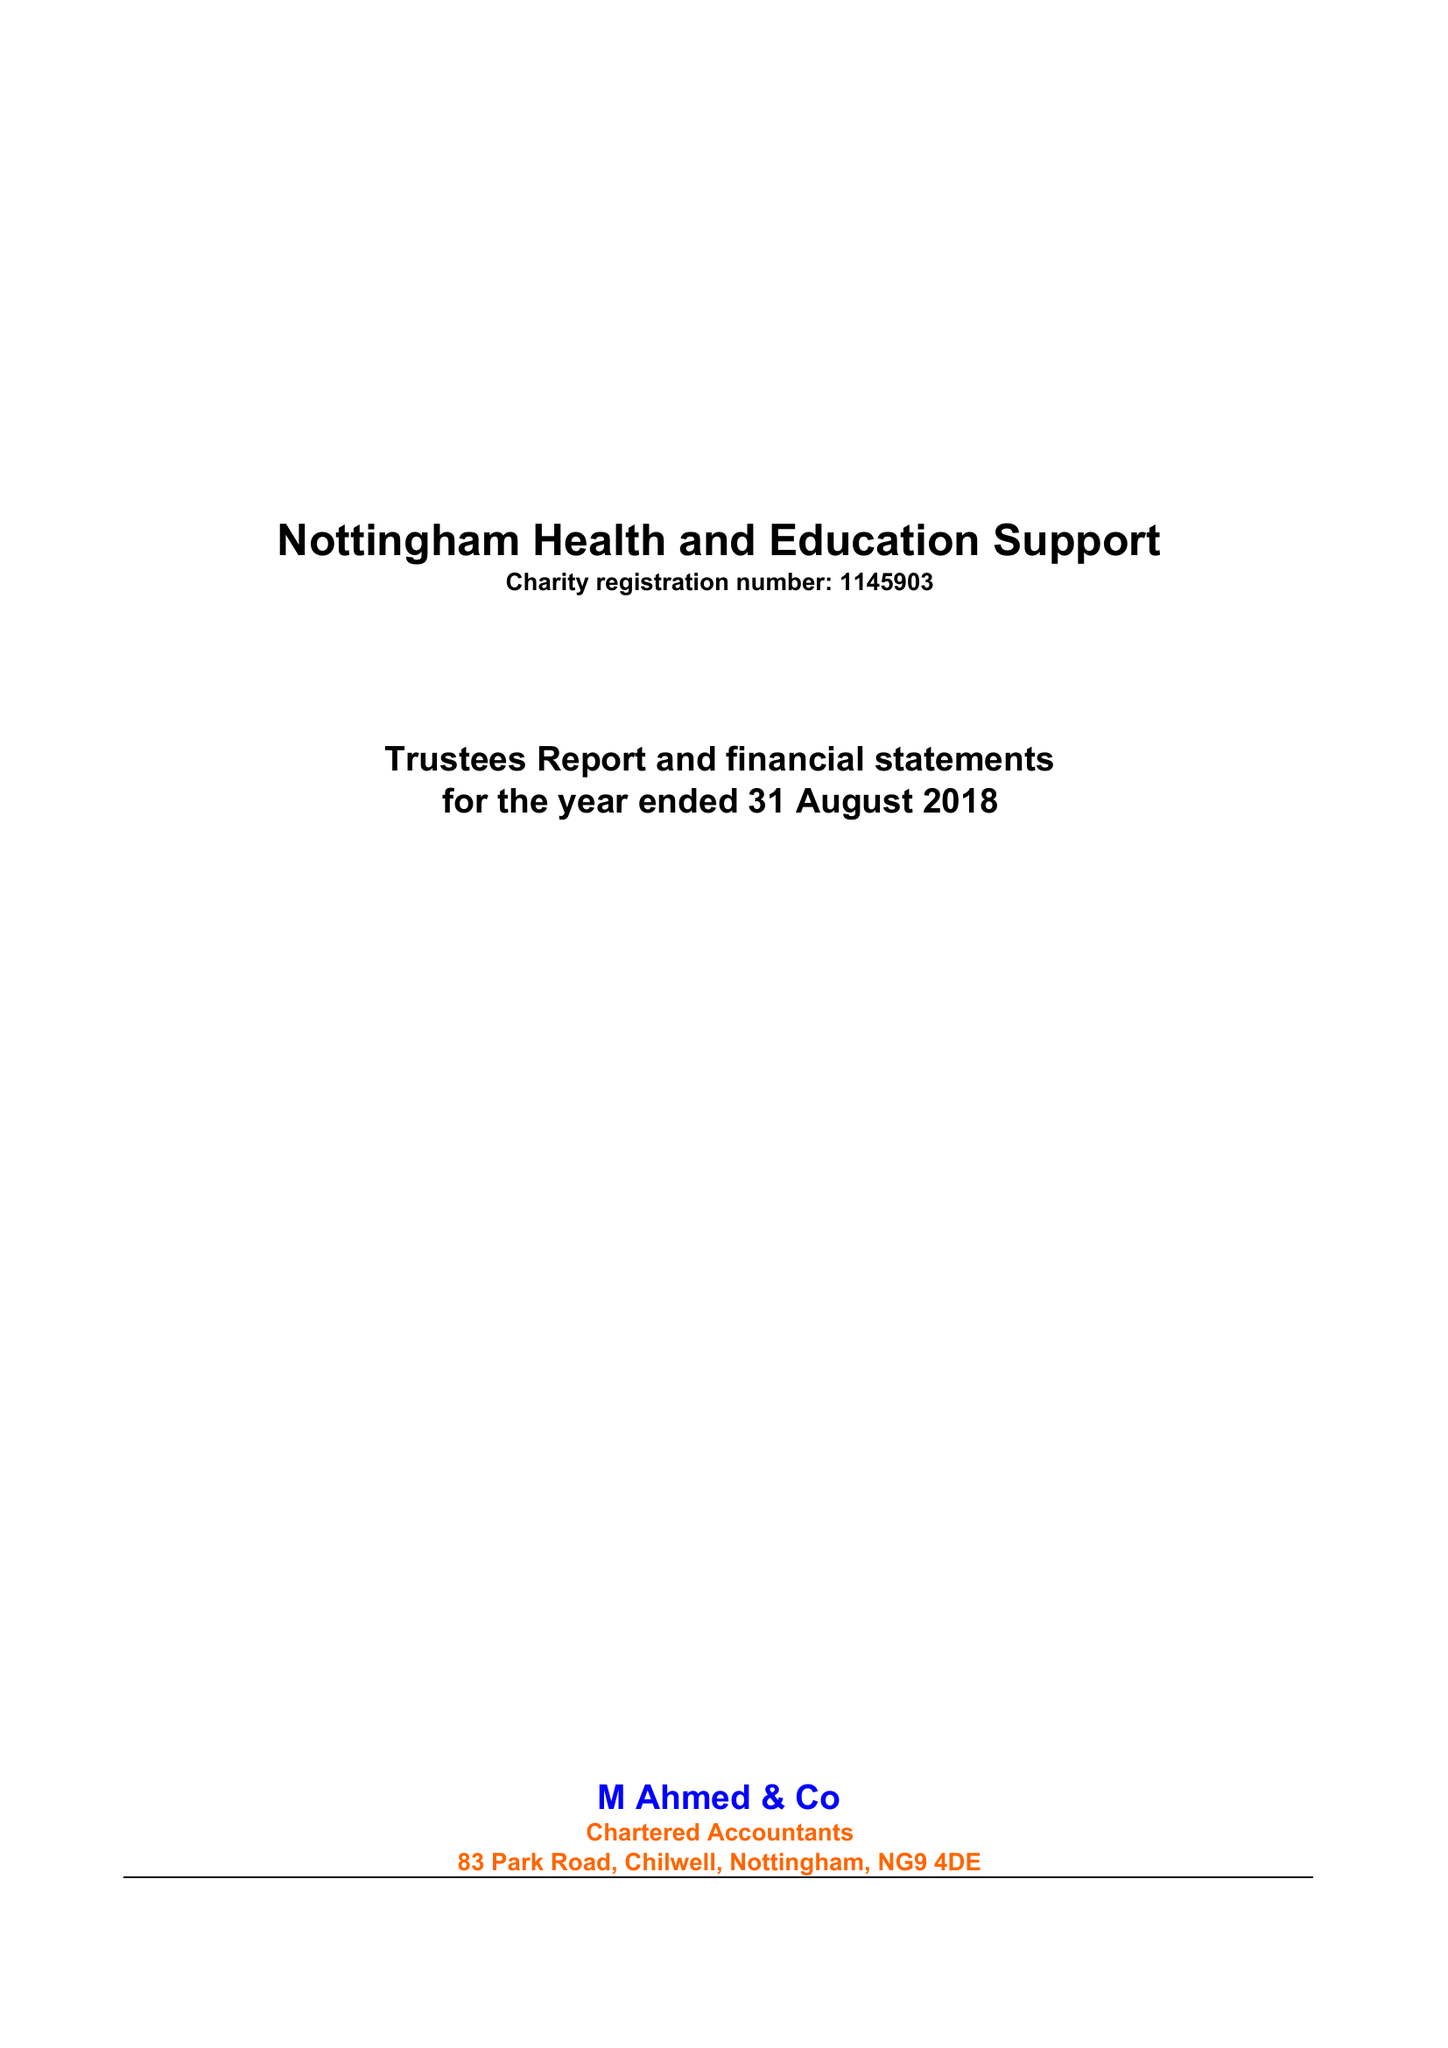What is the value for the spending_annually_in_british_pounds?
Answer the question using a single word or phrase. 72947.00 